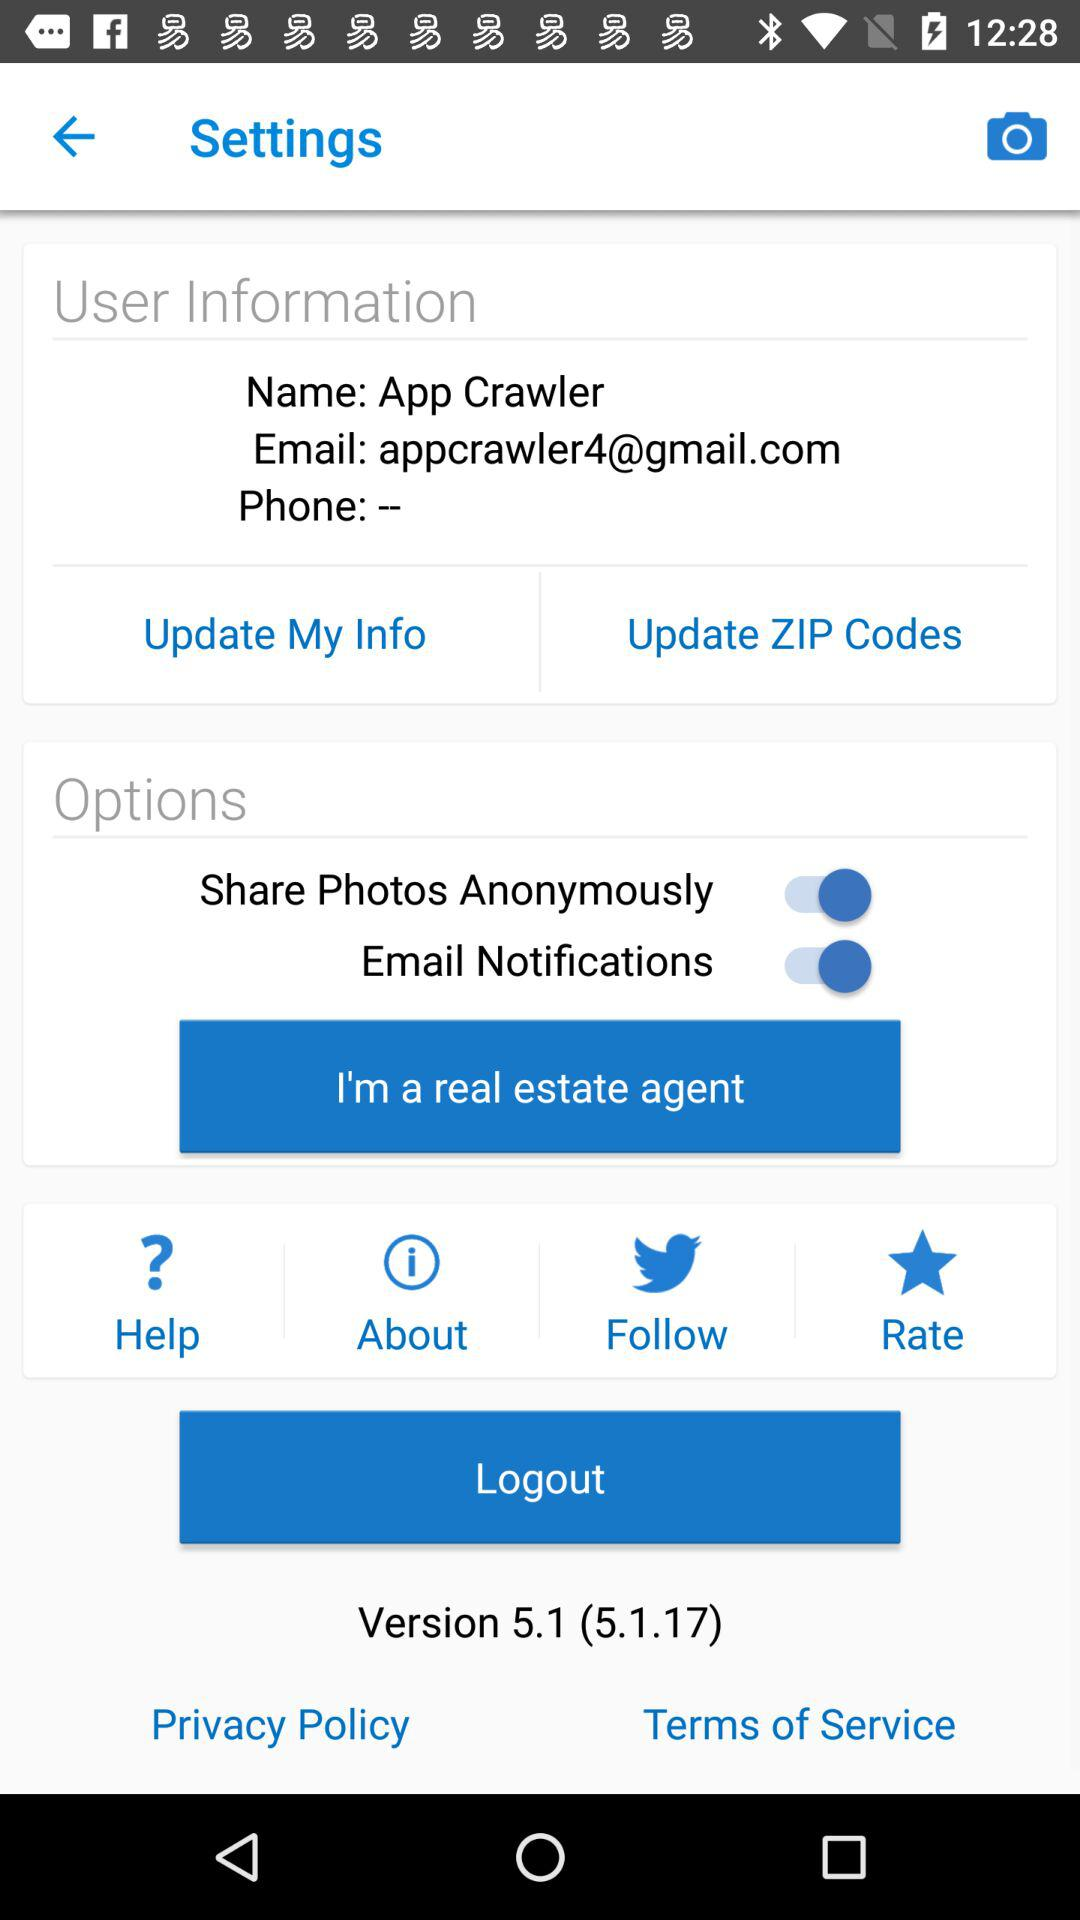What is the status of the "Email Notifications" setting? The status of the "Email Notifications" setting is "on". 